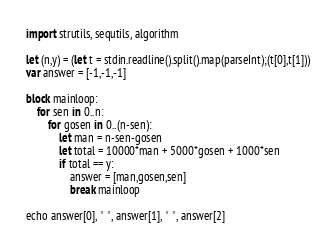Convert code to text. <code><loc_0><loc_0><loc_500><loc_500><_Nim_>import strutils, sequtils, algorithm

let (n,y) = (let t = stdin.readline().split().map(parseInt);(t[0],t[1]))
var answer = [-1,-1,-1]

block mainloop:
    for sen in 0..n:
        for gosen in 0..(n-sen):
            let man = n-sen-gosen
            let total = 10000*man + 5000*gosen + 1000*sen 
            if total == y:
                answer = [man,gosen,sen]               
                break mainloop

echo answer[0], " ", answer[1], " ", answer[2]</code> 